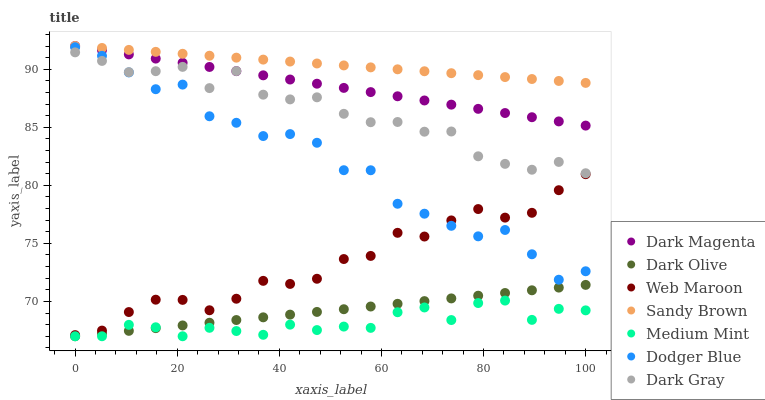Does Medium Mint have the minimum area under the curve?
Answer yes or no. Yes. Does Sandy Brown have the maximum area under the curve?
Answer yes or no. Yes. Does Dark Magenta have the minimum area under the curve?
Answer yes or no. No. Does Dark Magenta have the maximum area under the curve?
Answer yes or no. No. Is Dark Olive the smoothest?
Answer yes or no. Yes. Is Dodger Blue the roughest?
Answer yes or no. Yes. Is Dark Magenta the smoothest?
Answer yes or no. No. Is Dark Magenta the roughest?
Answer yes or no. No. Does Medium Mint have the lowest value?
Answer yes or no. Yes. Does Dark Magenta have the lowest value?
Answer yes or no. No. Does Sandy Brown have the highest value?
Answer yes or no. Yes. Does Dark Olive have the highest value?
Answer yes or no. No. Is Dark Olive less than Dodger Blue?
Answer yes or no. Yes. Is Sandy Brown greater than Medium Mint?
Answer yes or no. Yes. Does Web Maroon intersect Dodger Blue?
Answer yes or no. Yes. Is Web Maroon less than Dodger Blue?
Answer yes or no. No. Is Web Maroon greater than Dodger Blue?
Answer yes or no. No. Does Dark Olive intersect Dodger Blue?
Answer yes or no. No. 